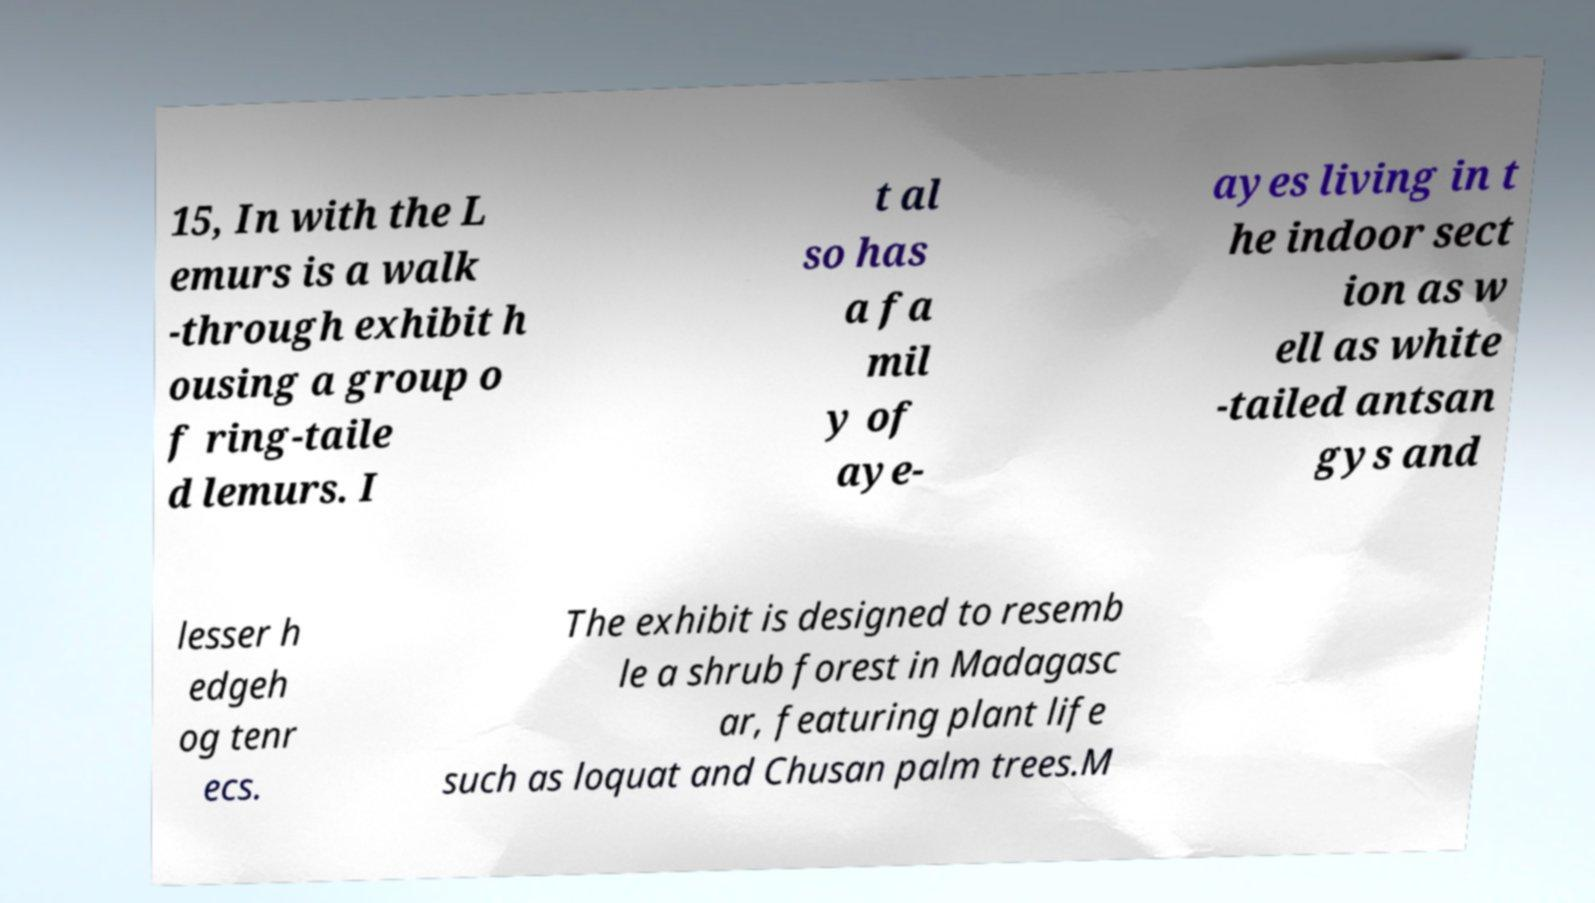I need the written content from this picture converted into text. Can you do that? 15, In with the L emurs is a walk -through exhibit h ousing a group o f ring-taile d lemurs. I t al so has a fa mil y of aye- ayes living in t he indoor sect ion as w ell as white -tailed antsan gys and lesser h edgeh og tenr ecs. The exhibit is designed to resemb le a shrub forest in Madagasc ar, featuring plant life such as loquat and Chusan palm trees.M 